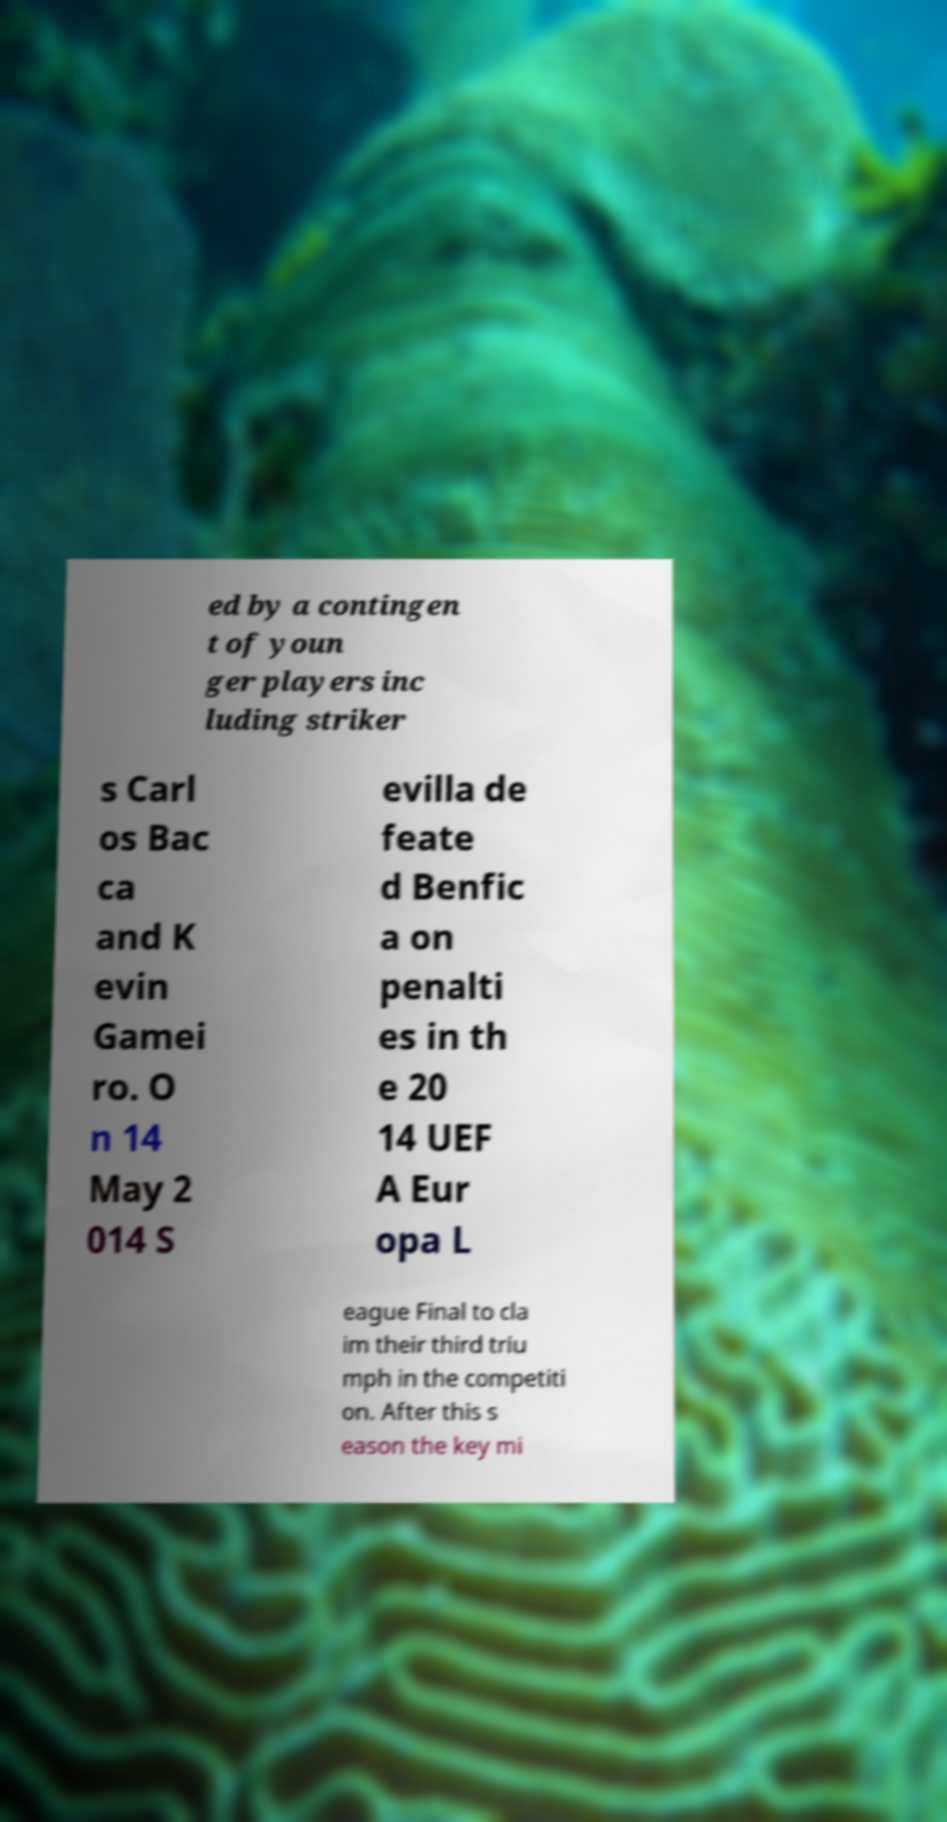What messages or text are displayed in this image? I need them in a readable, typed format. ed by a contingen t of youn ger players inc luding striker s Carl os Bac ca and K evin Gamei ro. O n 14 May 2 014 S evilla de feate d Benfic a on penalti es in th e 20 14 UEF A Eur opa L eague Final to cla im their third triu mph in the competiti on. After this s eason the key mi 